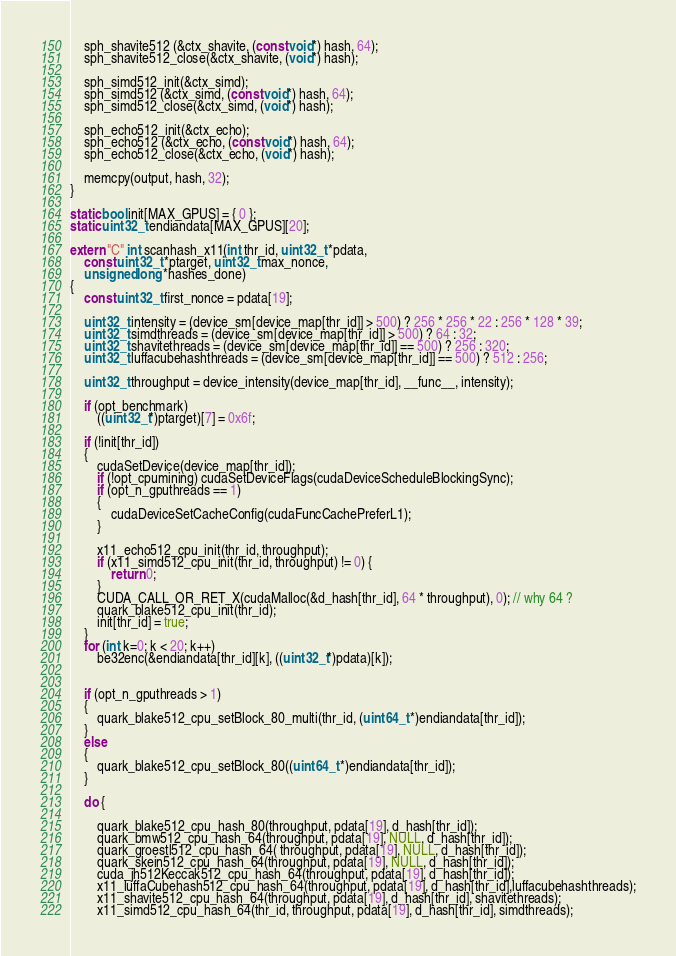<code> <loc_0><loc_0><loc_500><loc_500><_Cuda_>	sph_shavite512 (&ctx_shavite, (const void*) hash, 64);
	sph_shavite512_close(&ctx_shavite, (void*) hash);

	sph_simd512_init(&ctx_simd);
	sph_simd512 (&ctx_simd, (const void*) hash, 64);
	sph_simd512_close(&ctx_simd, (void*) hash);

	sph_echo512_init(&ctx_echo);
	sph_echo512 (&ctx_echo, (const void*) hash, 64);
	sph_echo512_close(&ctx_echo, (void*) hash);

	memcpy(output, hash, 32);
}

static bool init[MAX_GPUS] = { 0 };
static uint32_t endiandata[MAX_GPUS][20];

extern "C" int scanhash_x11(int thr_id, uint32_t *pdata,
    const uint32_t *ptarget, uint32_t max_nonce,
    unsigned long *hashes_done)
{
	const uint32_t first_nonce = pdata[19];

	uint32_t intensity = (device_sm[device_map[thr_id]] > 500) ? 256 * 256 * 22 : 256 * 128 * 39;
	uint32_t simdthreads = (device_sm[device_map[thr_id]] > 500) ? 64 : 32;
	uint32_t shavitethreads = (device_sm[device_map[thr_id]] == 500) ? 256 : 320;	
	uint32_t luffacubehashthreads = (device_sm[device_map[thr_id]] == 500) ? 512 : 256;

	uint32_t throughput = device_intensity(device_map[thr_id], __func__, intensity);

	if (opt_benchmark)
		((uint32_t*)ptarget)[7] = 0x6f;

	if (!init[thr_id])
	{
		cudaSetDevice(device_map[thr_id]);
		if (!opt_cpumining) cudaSetDeviceFlags(cudaDeviceScheduleBlockingSync);
		if (opt_n_gputhreads == 1)
		{
			cudaDeviceSetCacheConfig(cudaFuncCachePreferL1);
		}

		x11_echo512_cpu_init(thr_id, throughput);
		if (x11_simd512_cpu_init(thr_id, throughput) != 0) {
			return 0;
		}
		CUDA_CALL_OR_RET_X(cudaMalloc(&d_hash[thr_id], 64 * throughput), 0); // why 64 ?
		quark_blake512_cpu_init(thr_id);
		init[thr_id] = true;
	}
	for (int k=0; k < 20; k++)
		be32enc(&endiandata[thr_id][k], ((uint32_t*)pdata)[k]);


	if (opt_n_gputhreads > 1)
	{
		quark_blake512_cpu_setBlock_80_multi(thr_id, (uint64_t *)endiandata[thr_id]);
	}
	else
	{
		quark_blake512_cpu_setBlock_80((uint64_t *)endiandata[thr_id]);
	}

	do {

		quark_blake512_cpu_hash_80(throughput, pdata[19], d_hash[thr_id]);
		quark_bmw512_cpu_hash_64(throughput, pdata[19], NULL, d_hash[thr_id]);
		quark_groestl512_cpu_hash_64( throughput, pdata[19], NULL, d_hash[thr_id]);
		quark_skein512_cpu_hash_64(throughput, pdata[19], NULL, d_hash[thr_id]);
		cuda_jh512Keccak512_cpu_hash_64(throughput, pdata[19], d_hash[thr_id]);
		x11_luffaCubehash512_cpu_hash_64(throughput, pdata[19], d_hash[thr_id],luffacubehashthreads);
		x11_shavite512_cpu_hash_64(throughput, pdata[19], d_hash[thr_id], shavitethreads);
		x11_simd512_cpu_hash_64(thr_id, throughput, pdata[19], d_hash[thr_id], simdthreads);</code> 